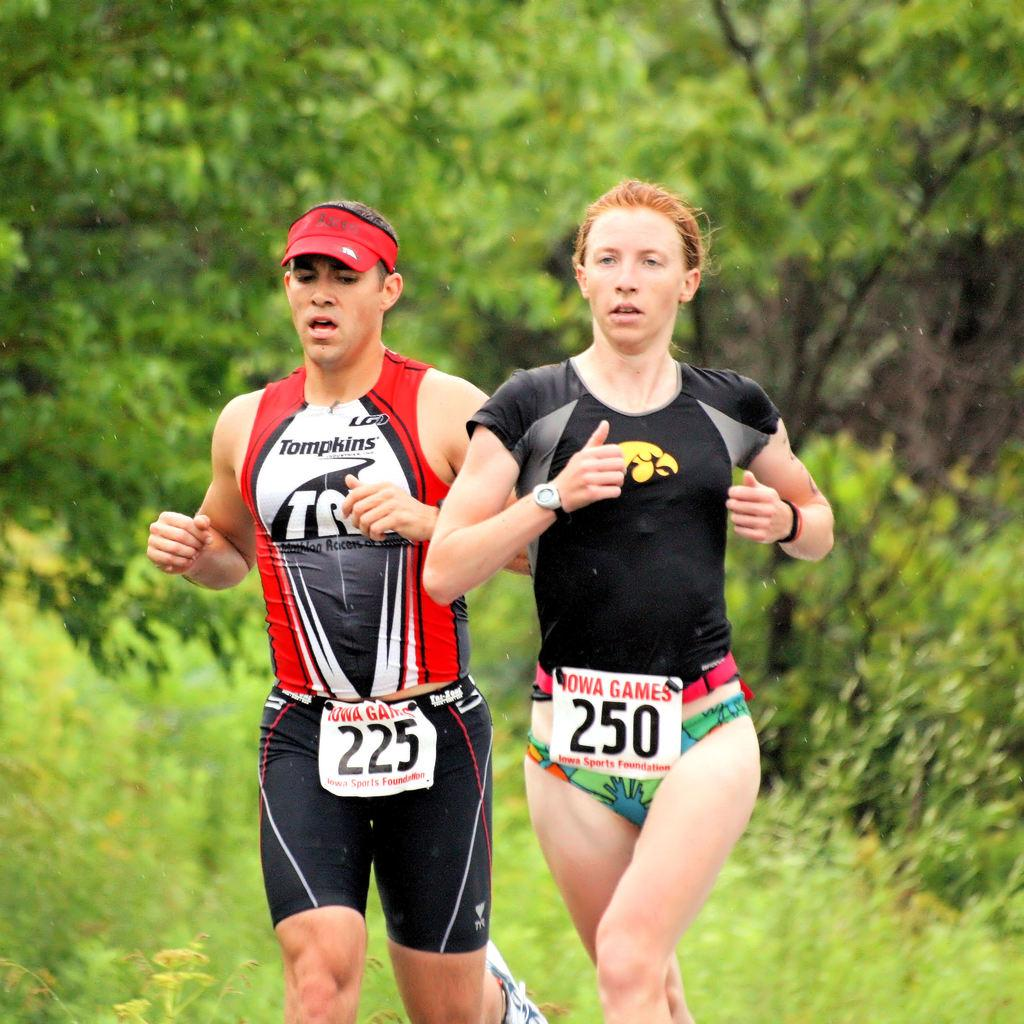Provide a one-sentence caption for the provided image. A woman runs in a race with the participant bib number 250. 